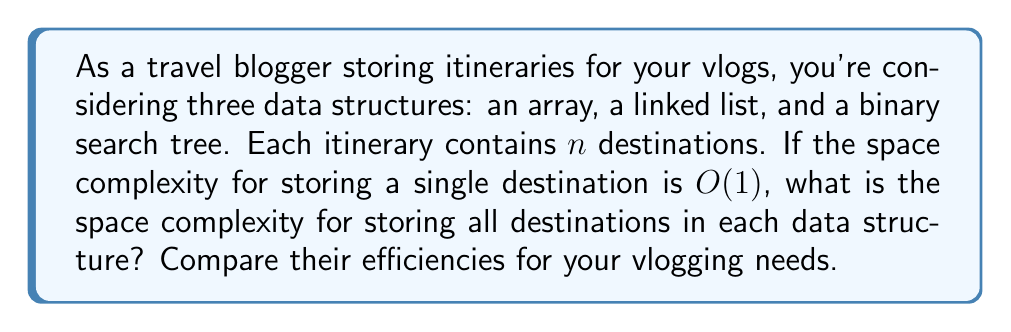Solve this math problem. Let's analyze the space complexity for each data structure:

1. Array:
   - An array stores elements in contiguous memory locations.
   - For $n$ destinations, we need $n$ memory slots.
   - Space complexity: $O(n)$

2. Linked List:
   - A linked list stores elements in nodes, each containing the data and a pointer to the next node.
   - For $n$ destinations, we need $n$ nodes, each with a data field and a pointer.
   - The pointer requires additional space, but it's constant for each node.
   - Space complexity: $O(n)$

3. Binary Search Tree (BST):
   - A BST stores elements in nodes, each containing the data and pointers to left and right children.
   - For $n$ destinations, we need $n$ nodes, each with a data field and two pointers.
   - The pointers require additional space, but it's constant for each node.
   - Space complexity: $O(n)$

Comparison:
All three data structures have a space complexity of $O(n)$, meaning they grow linearly with the number of destinations. However, there are practical differences:

- Arrays are most space-efficient as they don't require additional pointer storage.
- Linked lists and BSTs require extra space for pointers but offer more flexibility for insertions and deletions.
- BSTs provide faster search operations, which could be beneficial for finding specific destinations in your vlogs.

For vlogging needs, consider:
- If your itineraries are fixed and you frequently access destinations by index, an array might be most suitable.
- If you often add or remove destinations mid-trip, a linked list could be more convenient.
- If you need to quickly search for destinations or maintain them in a sorted order, a BST would be advantageous.
Answer: The space complexity for storing $n$ destinations in an array, linked list, or binary search tree is $O(n)$ for all three data structures. 